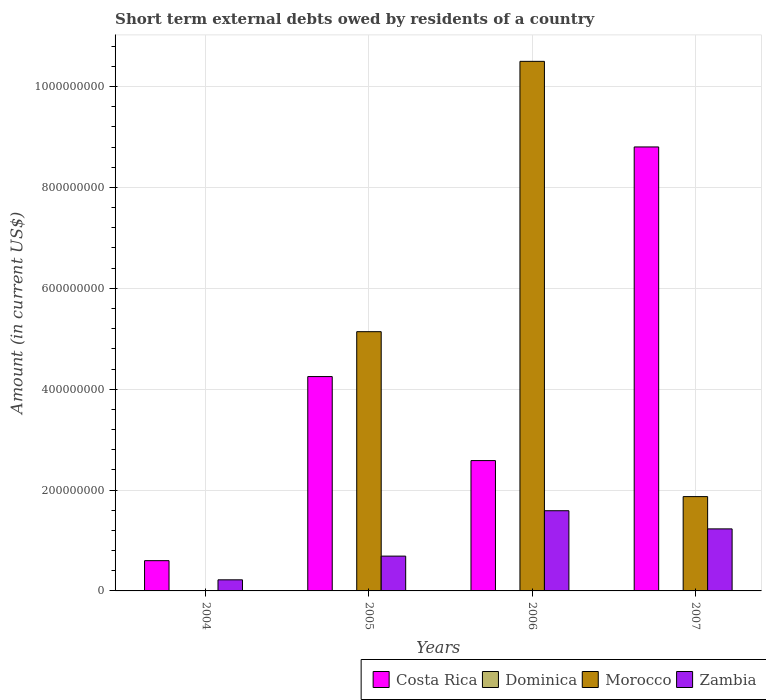How many different coloured bars are there?
Your answer should be compact. 3. How many groups of bars are there?
Make the answer very short. 4. Are the number of bars per tick equal to the number of legend labels?
Offer a very short reply. No. Are the number of bars on each tick of the X-axis equal?
Make the answer very short. No. How many bars are there on the 3rd tick from the right?
Your answer should be very brief. 3. What is the amount of short-term external debts owed by residents in Costa Rica in 2007?
Offer a terse response. 8.80e+08. Across all years, what is the maximum amount of short-term external debts owed by residents in Zambia?
Provide a short and direct response. 1.59e+08. Across all years, what is the minimum amount of short-term external debts owed by residents in Dominica?
Keep it short and to the point. 0. In which year was the amount of short-term external debts owed by residents in Costa Rica maximum?
Offer a very short reply. 2007. What is the total amount of short-term external debts owed by residents in Costa Rica in the graph?
Ensure brevity in your answer.  1.62e+09. What is the difference between the amount of short-term external debts owed by residents in Zambia in 2004 and that in 2006?
Your answer should be compact. -1.37e+08. What is the average amount of short-term external debts owed by residents in Zambia per year?
Offer a terse response. 9.32e+07. In the year 2005, what is the difference between the amount of short-term external debts owed by residents in Morocco and amount of short-term external debts owed by residents in Zambia?
Your answer should be compact. 4.45e+08. What is the ratio of the amount of short-term external debts owed by residents in Costa Rica in 2005 to that in 2007?
Ensure brevity in your answer.  0.48. Is the amount of short-term external debts owed by residents in Morocco in 2005 less than that in 2006?
Make the answer very short. Yes. Is the difference between the amount of short-term external debts owed by residents in Morocco in 2005 and 2007 greater than the difference between the amount of short-term external debts owed by residents in Zambia in 2005 and 2007?
Offer a terse response. Yes. What is the difference between the highest and the second highest amount of short-term external debts owed by residents in Morocco?
Your answer should be very brief. 5.36e+08. What is the difference between the highest and the lowest amount of short-term external debts owed by residents in Morocco?
Keep it short and to the point. 1.05e+09. Is the sum of the amount of short-term external debts owed by residents in Zambia in 2004 and 2007 greater than the maximum amount of short-term external debts owed by residents in Morocco across all years?
Make the answer very short. No. Is it the case that in every year, the sum of the amount of short-term external debts owed by residents in Dominica and amount of short-term external debts owed by residents in Zambia is greater than the amount of short-term external debts owed by residents in Morocco?
Provide a succinct answer. No. Are all the bars in the graph horizontal?
Keep it short and to the point. No. How many years are there in the graph?
Provide a succinct answer. 4. What is the difference between two consecutive major ticks on the Y-axis?
Your response must be concise. 2.00e+08. Are the values on the major ticks of Y-axis written in scientific E-notation?
Your answer should be compact. No. Does the graph contain any zero values?
Keep it short and to the point. Yes. Does the graph contain grids?
Your response must be concise. Yes. How many legend labels are there?
Offer a terse response. 4. What is the title of the graph?
Your answer should be compact. Short term external debts owed by residents of a country. Does "East Asia (all income levels)" appear as one of the legend labels in the graph?
Provide a succinct answer. No. What is the Amount (in current US$) of Costa Rica in 2004?
Provide a short and direct response. 6.00e+07. What is the Amount (in current US$) in Zambia in 2004?
Give a very brief answer. 2.20e+07. What is the Amount (in current US$) in Costa Rica in 2005?
Provide a short and direct response. 4.25e+08. What is the Amount (in current US$) in Dominica in 2005?
Provide a succinct answer. 0. What is the Amount (in current US$) in Morocco in 2005?
Your answer should be very brief. 5.14e+08. What is the Amount (in current US$) of Zambia in 2005?
Offer a terse response. 6.90e+07. What is the Amount (in current US$) of Costa Rica in 2006?
Your answer should be very brief. 2.58e+08. What is the Amount (in current US$) in Morocco in 2006?
Your response must be concise. 1.05e+09. What is the Amount (in current US$) of Zambia in 2006?
Your response must be concise. 1.59e+08. What is the Amount (in current US$) of Costa Rica in 2007?
Offer a very short reply. 8.80e+08. What is the Amount (in current US$) in Morocco in 2007?
Give a very brief answer. 1.87e+08. What is the Amount (in current US$) in Zambia in 2007?
Your response must be concise. 1.23e+08. Across all years, what is the maximum Amount (in current US$) of Costa Rica?
Provide a succinct answer. 8.80e+08. Across all years, what is the maximum Amount (in current US$) of Morocco?
Make the answer very short. 1.05e+09. Across all years, what is the maximum Amount (in current US$) in Zambia?
Your response must be concise. 1.59e+08. Across all years, what is the minimum Amount (in current US$) of Costa Rica?
Your answer should be very brief. 6.00e+07. Across all years, what is the minimum Amount (in current US$) of Morocco?
Provide a short and direct response. 0. Across all years, what is the minimum Amount (in current US$) in Zambia?
Your answer should be compact. 2.20e+07. What is the total Amount (in current US$) of Costa Rica in the graph?
Offer a terse response. 1.62e+09. What is the total Amount (in current US$) of Morocco in the graph?
Give a very brief answer. 1.75e+09. What is the total Amount (in current US$) in Zambia in the graph?
Ensure brevity in your answer.  3.73e+08. What is the difference between the Amount (in current US$) in Costa Rica in 2004 and that in 2005?
Keep it short and to the point. -3.65e+08. What is the difference between the Amount (in current US$) in Zambia in 2004 and that in 2005?
Give a very brief answer. -4.70e+07. What is the difference between the Amount (in current US$) of Costa Rica in 2004 and that in 2006?
Your answer should be compact. -1.98e+08. What is the difference between the Amount (in current US$) of Zambia in 2004 and that in 2006?
Your answer should be very brief. -1.37e+08. What is the difference between the Amount (in current US$) of Costa Rica in 2004 and that in 2007?
Your answer should be compact. -8.20e+08. What is the difference between the Amount (in current US$) in Zambia in 2004 and that in 2007?
Give a very brief answer. -1.01e+08. What is the difference between the Amount (in current US$) in Costa Rica in 2005 and that in 2006?
Give a very brief answer. 1.67e+08. What is the difference between the Amount (in current US$) of Morocco in 2005 and that in 2006?
Your answer should be very brief. -5.36e+08. What is the difference between the Amount (in current US$) of Zambia in 2005 and that in 2006?
Keep it short and to the point. -9.00e+07. What is the difference between the Amount (in current US$) in Costa Rica in 2005 and that in 2007?
Keep it short and to the point. -4.55e+08. What is the difference between the Amount (in current US$) in Morocco in 2005 and that in 2007?
Provide a succinct answer. 3.27e+08. What is the difference between the Amount (in current US$) in Zambia in 2005 and that in 2007?
Keep it short and to the point. -5.40e+07. What is the difference between the Amount (in current US$) in Costa Rica in 2006 and that in 2007?
Keep it short and to the point. -6.22e+08. What is the difference between the Amount (in current US$) in Morocco in 2006 and that in 2007?
Provide a short and direct response. 8.63e+08. What is the difference between the Amount (in current US$) of Zambia in 2006 and that in 2007?
Offer a very short reply. 3.60e+07. What is the difference between the Amount (in current US$) of Costa Rica in 2004 and the Amount (in current US$) of Morocco in 2005?
Your answer should be compact. -4.54e+08. What is the difference between the Amount (in current US$) of Costa Rica in 2004 and the Amount (in current US$) of Zambia in 2005?
Offer a very short reply. -9.00e+06. What is the difference between the Amount (in current US$) of Costa Rica in 2004 and the Amount (in current US$) of Morocco in 2006?
Offer a terse response. -9.90e+08. What is the difference between the Amount (in current US$) of Costa Rica in 2004 and the Amount (in current US$) of Zambia in 2006?
Provide a short and direct response. -9.90e+07. What is the difference between the Amount (in current US$) in Costa Rica in 2004 and the Amount (in current US$) in Morocco in 2007?
Keep it short and to the point. -1.27e+08. What is the difference between the Amount (in current US$) of Costa Rica in 2004 and the Amount (in current US$) of Zambia in 2007?
Ensure brevity in your answer.  -6.30e+07. What is the difference between the Amount (in current US$) in Costa Rica in 2005 and the Amount (in current US$) in Morocco in 2006?
Your answer should be very brief. -6.25e+08. What is the difference between the Amount (in current US$) of Costa Rica in 2005 and the Amount (in current US$) of Zambia in 2006?
Your response must be concise. 2.66e+08. What is the difference between the Amount (in current US$) in Morocco in 2005 and the Amount (in current US$) in Zambia in 2006?
Provide a succinct answer. 3.55e+08. What is the difference between the Amount (in current US$) in Costa Rica in 2005 and the Amount (in current US$) in Morocco in 2007?
Offer a very short reply. 2.38e+08. What is the difference between the Amount (in current US$) in Costa Rica in 2005 and the Amount (in current US$) in Zambia in 2007?
Offer a terse response. 3.02e+08. What is the difference between the Amount (in current US$) of Morocco in 2005 and the Amount (in current US$) of Zambia in 2007?
Your answer should be compact. 3.91e+08. What is the difference between the Amount (in current US$) of Costa Rica in 2006 and the Amount (in current US$) of Morocco in 2007?
Provide a short and direct response. 7.14e+07. What is the difference between the Amount (in current US$) of Costa Rica in 2006 and the Amount (in current US$) of Zambia in 2007?
Provide a succinct answer. 1.35e+08. What is the difference between the Amount (in current US$) of Morocco in 2006 and the Amount (in current US$) of Zambia in 2007?
Offer a terse response. 9.27e+08. What is the average Amount (in current US$) of Costa Rica per year?
Your response must be concise. 4.06e+08. What is the average Amount (in current US$) in Dominica per year?
Keep it short and to the point. 0. What is the average Amount (in current US$) in Morocco per year?
Make the answer very short. 4.38e+08. What is the average Amount (in current US$) of Zambia per year?
Give a very brief answer. 9.32e+07. In the year 2004, what is the difference between the Amount (in current US$) in Costa Rica and Amount (in current US$) in Zambia?
Provide a short and direct response. 3.80e+07. In the year 2005, what is the difference between the Amount (in current US$) of Costa Rica and Amount (in current US$) of Morocco?
Give a very brief answer. -8.90e+07. In the year 2005, what is the difference between the Amount (in current US$) in Costa Rica and Amount (in current US$) in Zambia?
Ensure brevity in your answer.  3.56e+08. In the year 2005, what is the difference between the Amount (in current US$) of Morocco and Amount (in current US$) of Zambia?
Provide a short and direct response. 4.45e+08. In the year 2006, what is the difference between the Amount (in current US$) of Costa Rica and Amount (in current US$) of Morocco?
Offer a terse response. -7.92e+08. In the year 2006, what is the difference between the Amount (in current US$) in Costa Rica and Amount (in current US$) in Zambia?
Ensure brevity in your answer.  9.94e+07. In the year 2006, what is the difference between the Amount (in current US$) of Morocco and Amount (in current US$) of Zambia?
Offer a very short reply. 8.91e+08. In the year 2007, what is the difference between the Amount (in current US$) in Costa Rica and Amount (in current US$) in Morocco?
Your answer should be very brief. 6.93e+08. In the year 2007, what is the difference between the Amount (in current US$) in Costa Rica and Amount (in current US$) in Zambia?
Offer a very short reply. 7.57e+08. In the year 2007, what is the difference between the Amount (in current US$) of Morocco and Amount (in current US$) of Zambia?
Your answer should be very brief. 6.40e+07. What is the ratio of the Amount (in current US$) in Costa Rica in 2004 to that in 2005?
Your response must be concise. 0.14. What is the ratio of the Amount (in current US$) in Zambia in 2004 to that in 2005?
Provide a succinct answer. 0.32. What is the ratio of the Amount (in current US$) of Costa Rica in 2004 to that in 2006?
Offer a very short reply. 0.23. What is the ratio of the Amount (in current US$) in Zambia in 2004 to that in 2006?
Provide a short and direct response. 0.14. What is the ratio of the Amount (in current US$) in Costa Rica in 2004 to that in 2007?
Ensure brevity in your answer.  0.07. What is the ratio of the Amount (in current US$) in Zambia in 2004 to that in 2007?
Give a very brief answer. 0.18. What is the ratio of the Amount (in current US$) of Costa Rica in 2005 to that in 2006?
Your answer should be compact. 1.64. What is the ratio of the Amount (in current US$) in Morocco in 2005 to that in 2006?
Give a very brief answer. 0.49. What is the ratio of the Amount (in current US$) in Zambia in 2005 to that in 2006?
Provide a short and direct response. 0.43. What is the ratio of the Amount (in current US$) in Costa Rica in 2005 to that in 2007?
Make the answer very short. 0.48. What is the ratio of the Amount (in current US$) in Morocco in 2005 to that in 2007?
Give a very brief answer. 2.75. What is the ratio of the Amount (in current US$) in Zambia in 2005 to that in 2007?
Your response must be concise. 0.56. What is the ratio of the Amount (in current US$) in Costa Rica in 2006 to that in 2007?
Keep it short and to the point. 0.29. What is the ratio of the Amount (in current US$) in Morocco in 2006 to that in 2007?
Give a very brief answer. 5.62. What is the ratio of the Amount (in current US$) of Zambia in 2006 to that in 2007?
Provide a succinct answer. 1.29. What is the difference between the highest and the second highest Amount (in current US$) of Costa Rica?
Offer a terse response. 4.55e+08. What is the difference between the highest and the second highest Amount (in current US$) in Morocco?
Offer a terse response. 5.36e+08. What is the difference between the highest and the second highest Amount (in current US$) in Zambia?
Give a very brief answer. 3.60e+07. What is the difference between the highest and the lowest Amount (in current US$) of Costa Rica?
Keep it short and to the point. 8.20e+08. What is the difference between the highest and the lowest Amount (in current US$) of Morocco?
Ensure brevity in your answer.  1.05e+09. What is the difference between the highest and the lowest Amount (in current US$) of Zambia?
Provide a succinct answer. 1.37e+08. 